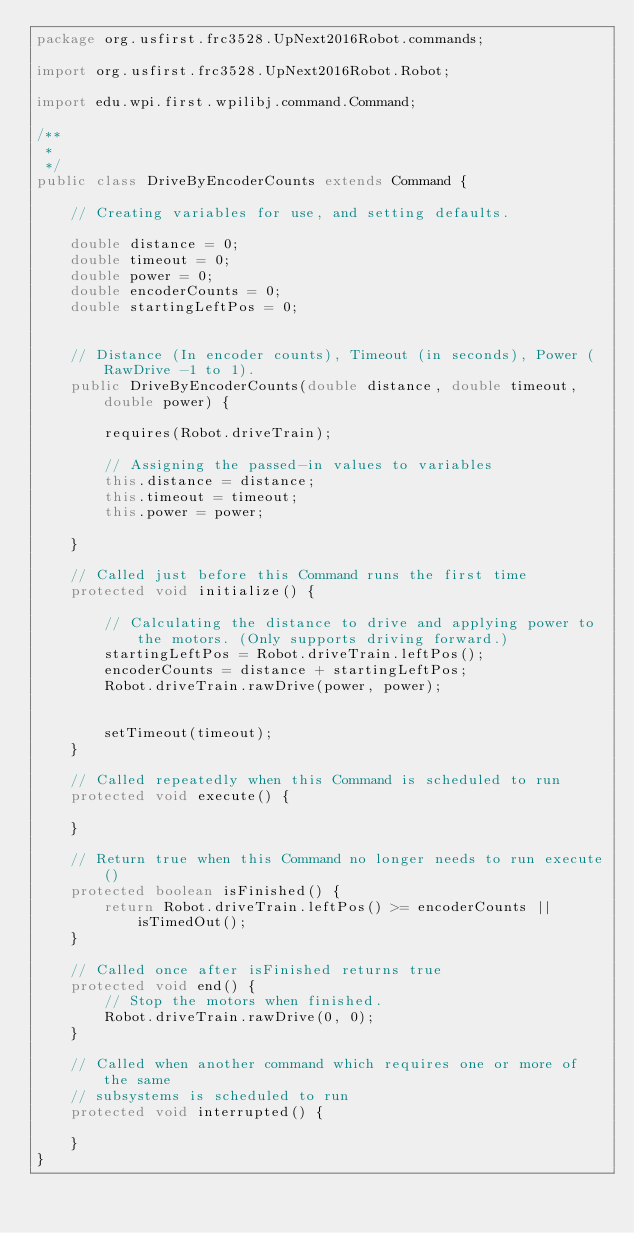<code> <loc_0><loc_0><loc_500><loc_500><_Java_>package org.usfirst.frc3528.UpNext2016Robot.commands;

import org.usfirst.frc3528.UpNext2016Robot.Robot;

import edu.wpi.first.wpilibj.command.Command;

/**
 *
 */
public class DriveByEncoderCounts extends Command {
	
	// Creating variables for use, and setting defaults.
	
	double distance = 0;
	double timeout = 0;
	double power = 0;
	double encoderCounts = 0;
	double startingLeftPos = 0;
	
	
	// Distance (In encoder counts), Timeout (in seconds), Power ( RawDrive -1 to 1).
    public DriveByEncoderCounts(double distance, double timeout, double power) {
        
    	requires(Robot.driveTrain);
    	
    	// Assigning the passed-in values to variables
    	this.distance = distance;
    	this.timeout = timeout;
    	this.power = power;
    	
    }

    // Called just before this Command runs the first time
    protected void initialize() {
    	
    	// Calculating the distance to drive and applying power to the motors. (Only supports driving forward.)
    	startingLeftPos = Robot.driveTrain.leftPos();
    	encoderCounts = distance + startingLeftPos;
    	Robot.driveTrain.rawDrive(power, power);
    	
    	
    	setTimeout(timeout);
    }

    // Called repeatedly when this Command is scheduled to run
    protected void execute() {
    	
    }

    // Return true when this Command no longer needs to run execute()
    protected boolean isFinished() {
        return Robot.driveTrain.leftPos() >= encoderCounts || isTimedOut();
    }

    // Called once after isFinished returns true
    protected void end() {
    	// Stop the motors when finished.
    	Robot.driveTrain.rawDrive(0, 0);
    }

    // Called when another command which requires one or more of the same
    // subsystems is scheduled to run
    protected void interrupted() {
    	
    }
}
</code> 